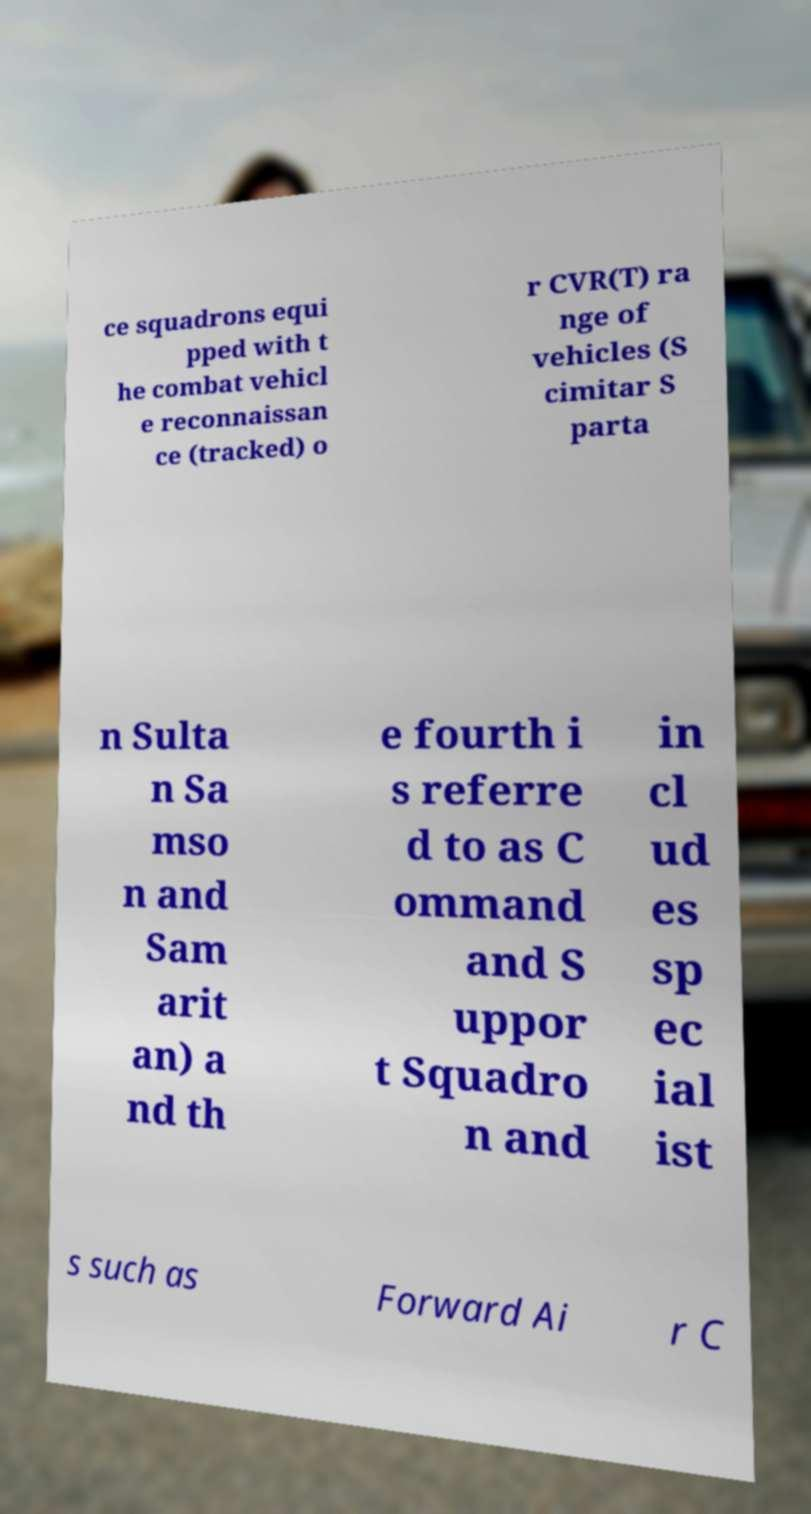Please read and relay the text visible in this image. What does it say? ce squadrons equi pped with t he combat vehicl e reconnaissan ce (tracked) o r CVR(T) ra nge of vehicles (S cimitar S parta n Sulta n Sa mso n and Sam arit an) a nd th e fourth i s referre d to as C ommand and S uppor t Squadro n and in cl ud es sp ec ial ist s such as Forward Ai r C 